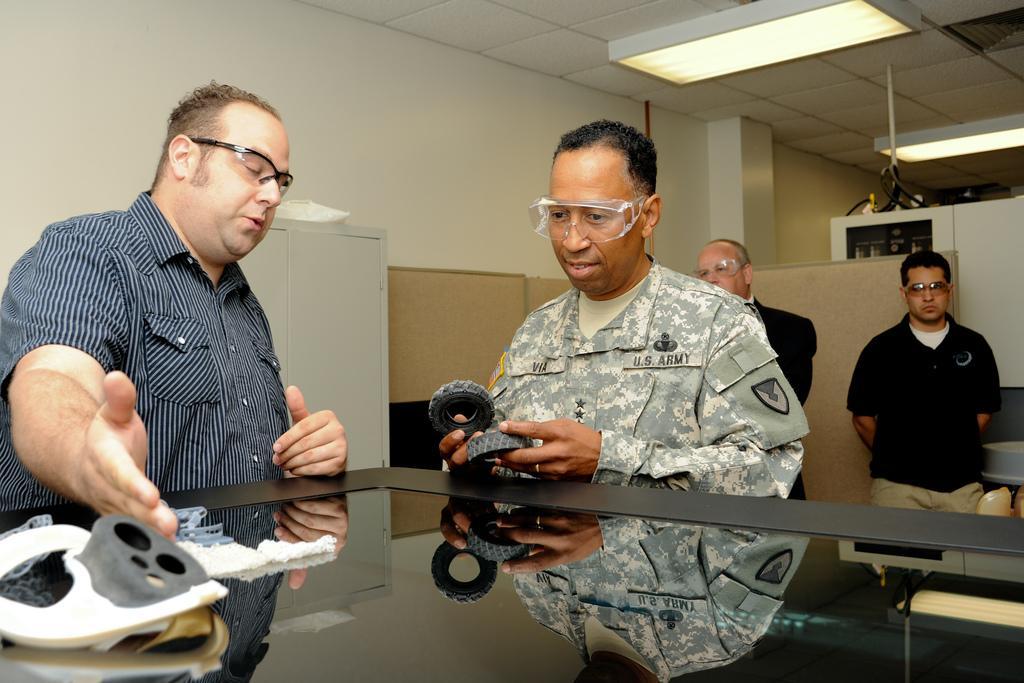Please provide a concise description of this image. In this image I can see there are two people standing at the table, the person at the right side is holding few objects and is wearing an army uniform. There are two other persons standing in the background and there are lights attached to the ceiling. 